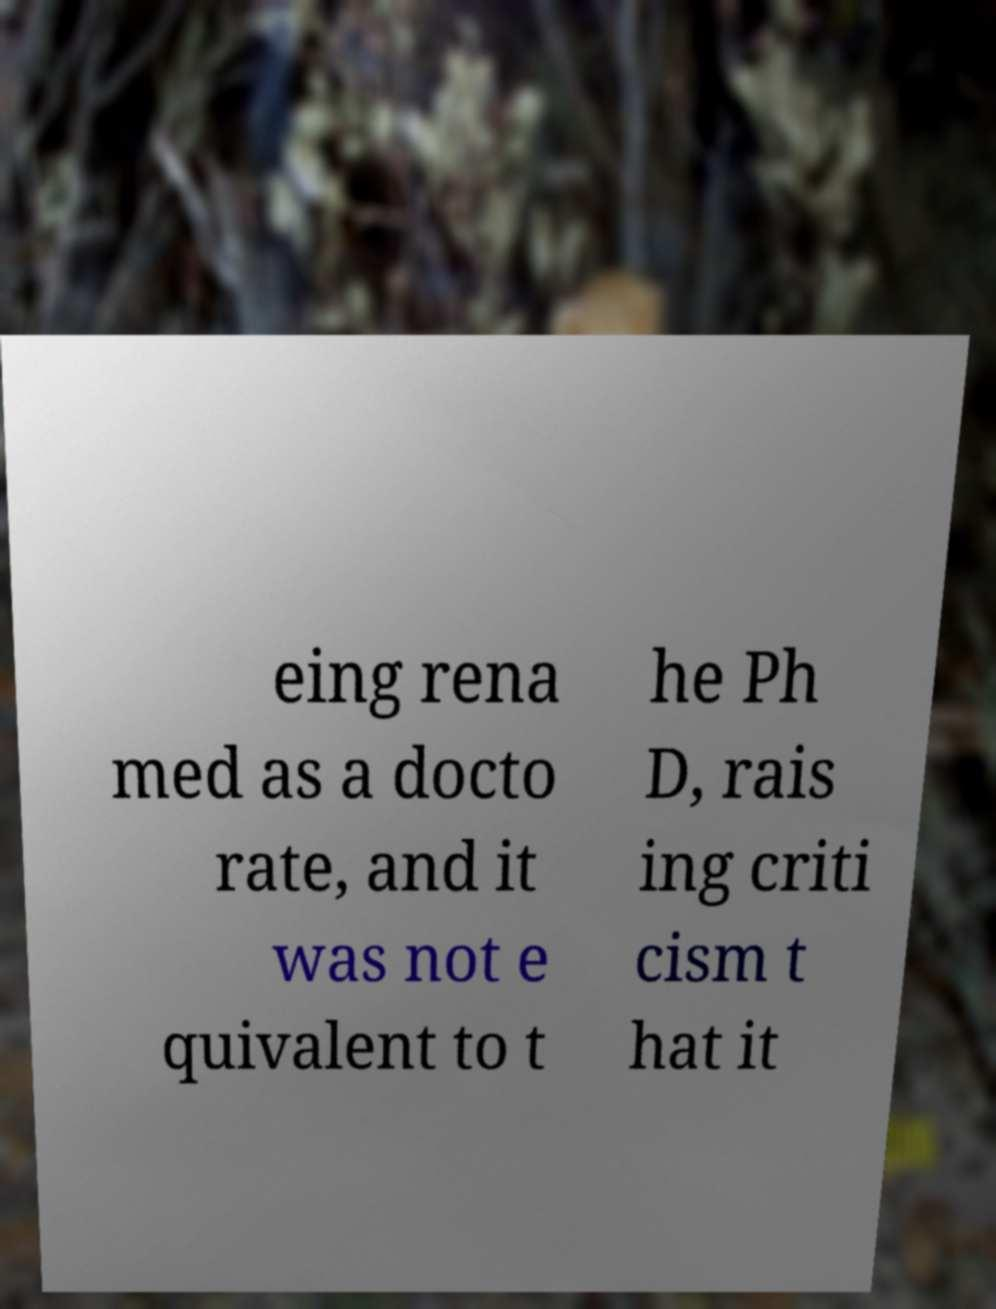I need the written content from this picture converted into text. Can you do that? eing rena med as a docto rate, and it was not e quivalent to t he Ph D, rais ing criti cism t hat it 